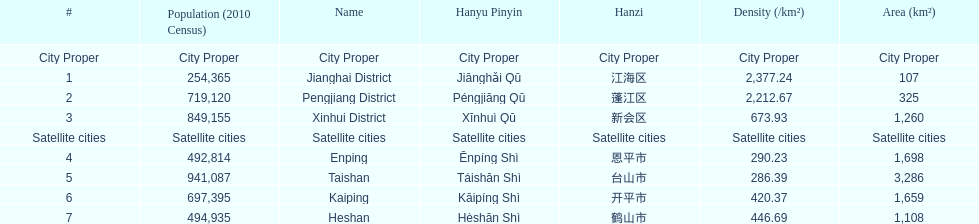What city proper has the smallest area in km2? Jianghai District. 